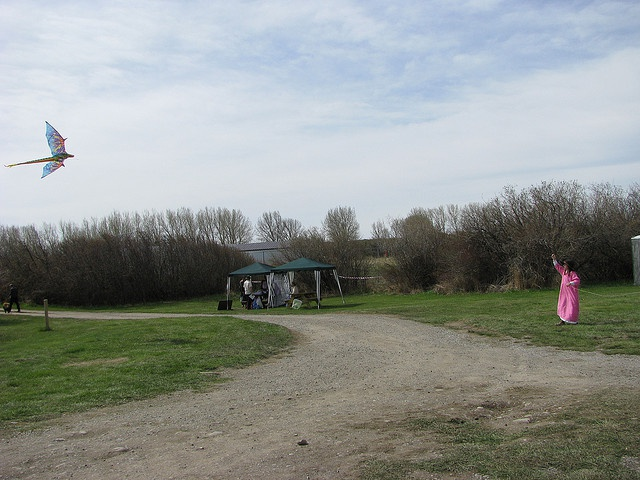Describe the objects in this image and their specific colors. I can see people in lavender, violet, purple, lightpink, and black tones, kite in lavender, darkgray, gray, and lightblue tones, bench in lavender, black, gray, and darkgreen tones, people in lavender, black, gray, and darkgreen tones, and people in lavender, black, gray, darkgray, and lightgray tones in this image. 